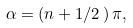Convert formula to latex. <formula><loc_0><loc_0><loc_500><loc_500>\alpha = ( n + 1 / 2 \, ) \, \pi ,</formula> 